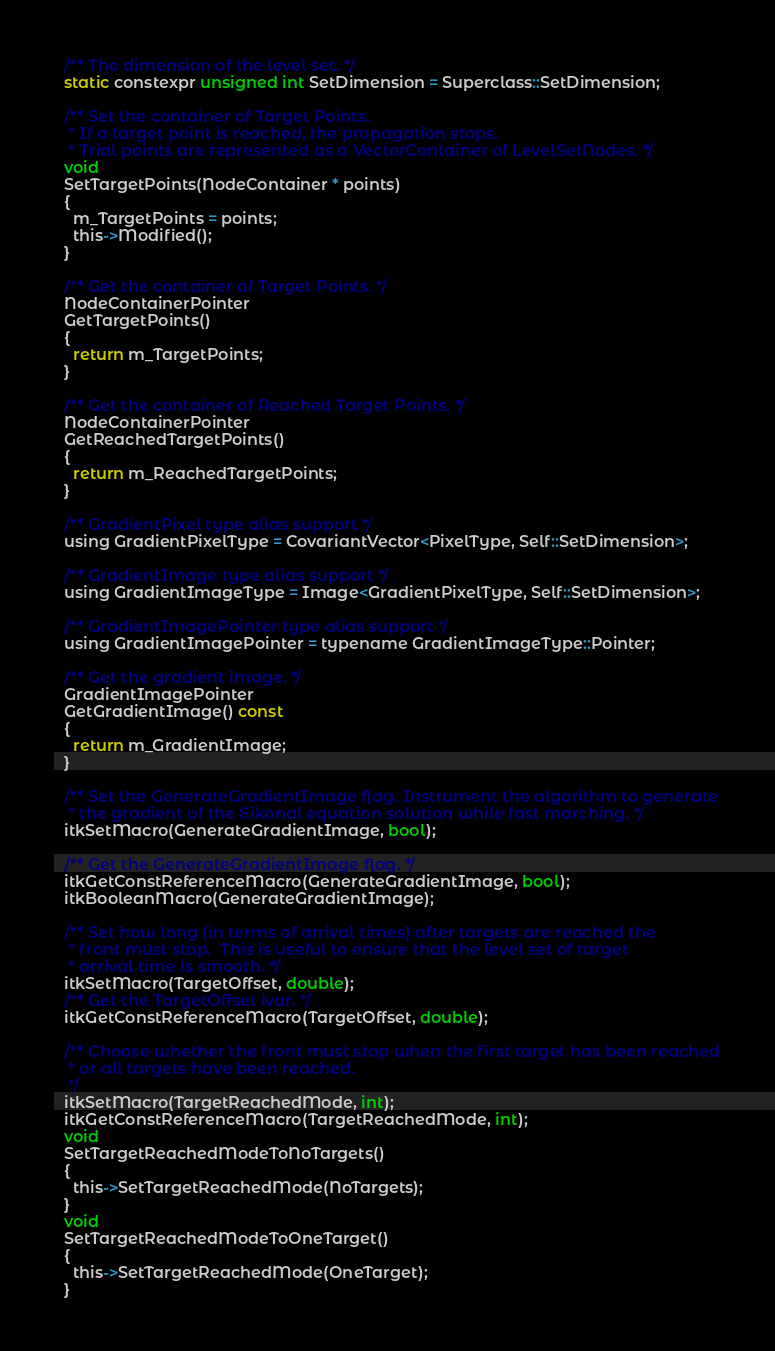Convert code to text. <code><loc_0><loc_0><loc_500><loc_500><_C_>  /** The dimension of the level set. */
  static constexpr unsigned int SetDimension = Superclass::SetDimension;

  /** Set the container of Target Points.
   * If a target point is reached, the propagation stops.
   * Trial points are represented as a VectorContainer of LevelSetNodes. */
  void
  SetTargetPoints(NodeContainer * points)
  {
    m_TargetPoints = points;
    this->Modified();
  }

  /** Get the container of Target Points. */
  NodeContainerPointer
  GetTargetPoints()
  {
    return m_TargetPoints;
  }

  /** Get the container of Reached Target Points. */
  NodeContainerPointer
  GetReachedTargetPoints()
  {
    return m_ReachedTargetPoints;
  }

  /** GradientPixel type alias support */
  using GradientPixelType = CovariantVector<PixelType, Self::SetDimension>;

  /** GradientImage type alias support */
  using GradientImageType = Image<GradientPixelType, Self::SetDimension>;

  /** GradientImagePointer type alias support */
  using GradientImagePointer = typename GradientImageType::Pointer;

  /** Get the gradient image. */
  GradientImagePointer
  GetGradientImage() const
  {
    return m_GradientImage;
  }

  /** Set the GenerateGradientImage flag. Instrument the algorithm to generate
   * the gradient of the Eikonal equation solution while fast marching. */
  itkSetMacro(GenerateGradientImage, bool);

  /** Get the GenerateGradientImage flag. */
  itkGetConstReferenceMacro(GenerateGradientImage, bool);
  itkBooleanMacro(GenerateGradientImage);

  /** Set how long (in terms of arrival times) after targets are reached the
   * front must stop.  This is useful to ensure that the level set of target
   * arrival time is smooth. */
  itkSetMacro(TargetOffset, double);
  /** Get the TargetOffset ivar. */
  itkGetConstReferenceMacro(TargetOffset, double);

  /** Choose whether the front must stop when the first target has been reached
   * or all targets have been reached.
   */
  itkSetMacro(TargetReachedMode, int);
  itkGetConstReferenceMacro(TargetReachedMode, int);
  void
  SetTargetReachedModeToNoTargets()
  {
    this->SetTargetReachedMode(NoTargets);
  }
  void
  SetTargetReachedModeToOneTarget()
  {
    this->SetTargetReachedMode(OneTarget);
  }</code> 